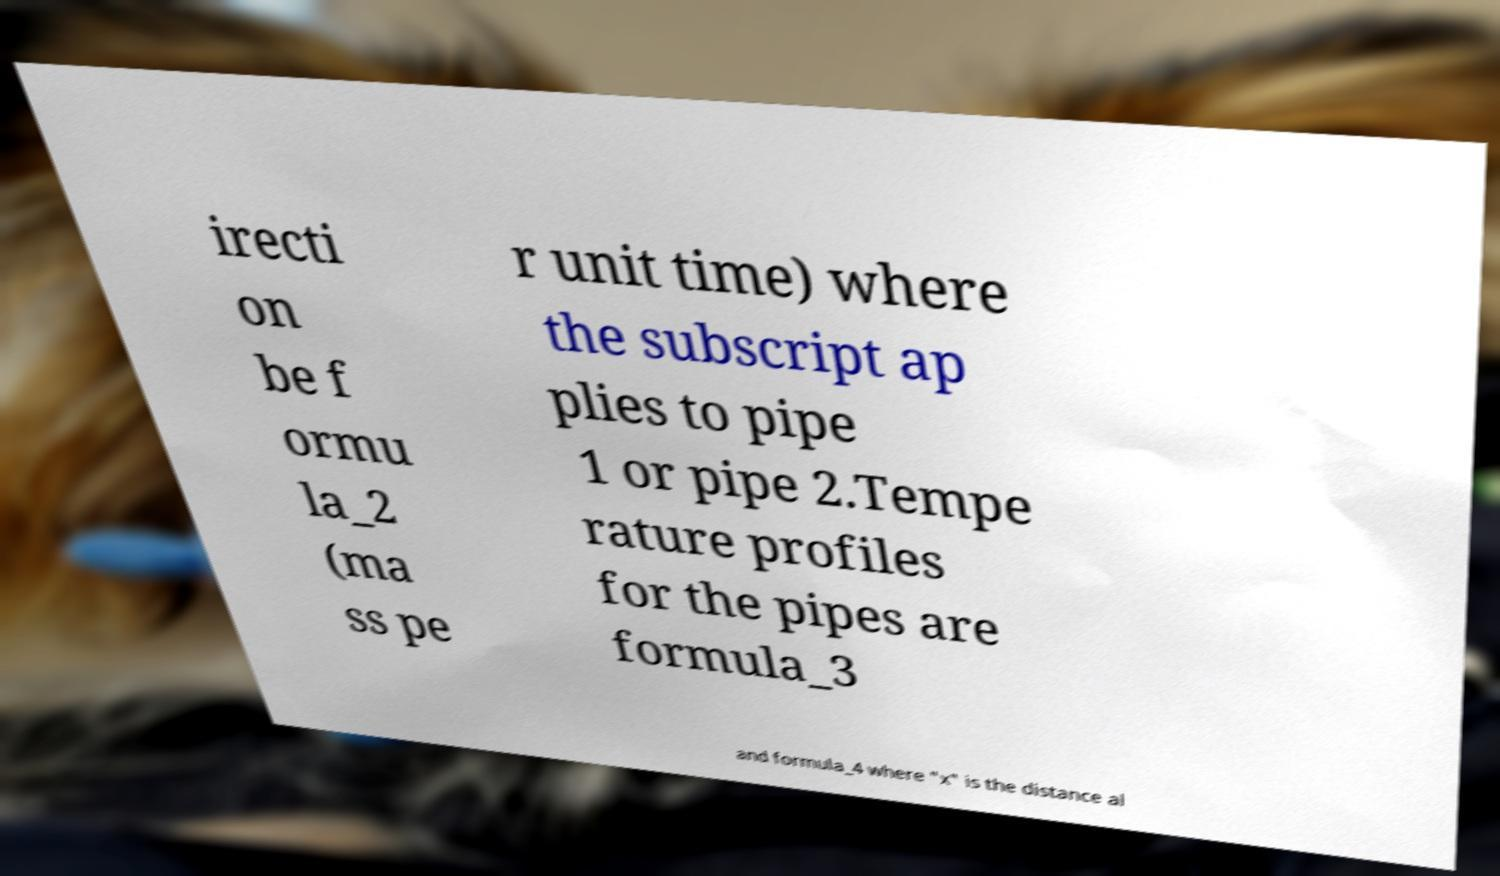Please read and relay the text visible in this image. What does it say? irecti on be f ormu la_2 (ma ss pe r unit time) where the subscript ap plies to pipe 1 or pipe 2.Tempe rature profiles for the pipes are formula_3 and formula_4 where "x" is the distance al 